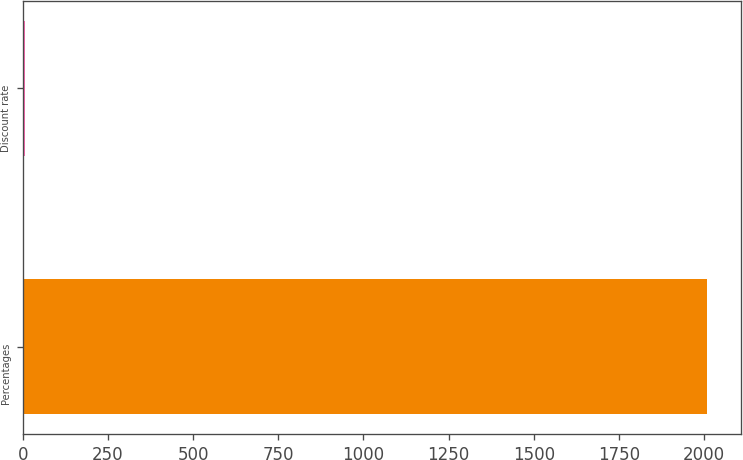Convert chart. <chart><loc_0><loc_0><loc_500><loc_500><bar_chart><fcel>Percentages<fcel>Discount rate<nl><fcel>2007<fcel>6<nl></chart> 